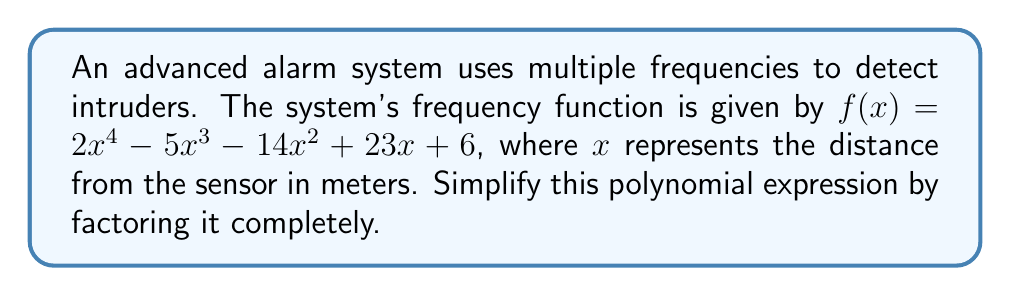Solve this math problem. To factor this polynomial completely, we'll follow these steps:

1) First, let's check if there are any common factors:
   There are no common factors for all terms.

2) Next, we'll use the rational root theorem to find potential roots:
   Factors of the constant term (6): ±1, ±2, ±3, ±6
   Factors of the leading coefficient (2): ±1, ±2

   Potential roots: ±1, ±2, ±3, ±1/2, ±3/2

3) Testing these roots, we find that 1 and -1/2 are roots.

4) Divide the polynomial by $(x-1)$ and $(x+\frac{1}{2})$:

   $f(x) = (x-1)(x+\frac{1}{2})(2x^2 - 4x - 6)$

5) Now focus on factoring $2x^2 - 4x - 6$:
   
   $2x^2 - 4x - 6 = 2(x^2 - 2x - 3)$
   $= 2(x-3)(x+1)$

6) Combining all factors:

   $f(x) = (x-1)(x+\frac{1}{2})(2)(x-3)(x+1)$

7) Simplify:

   $f(x) = 2(x-1)(x+\frac{1}{2})(x-3)(x+1)$
Answer: $2(x-1)(x+\frac{1}{2})(x-3)(x+1)$ 